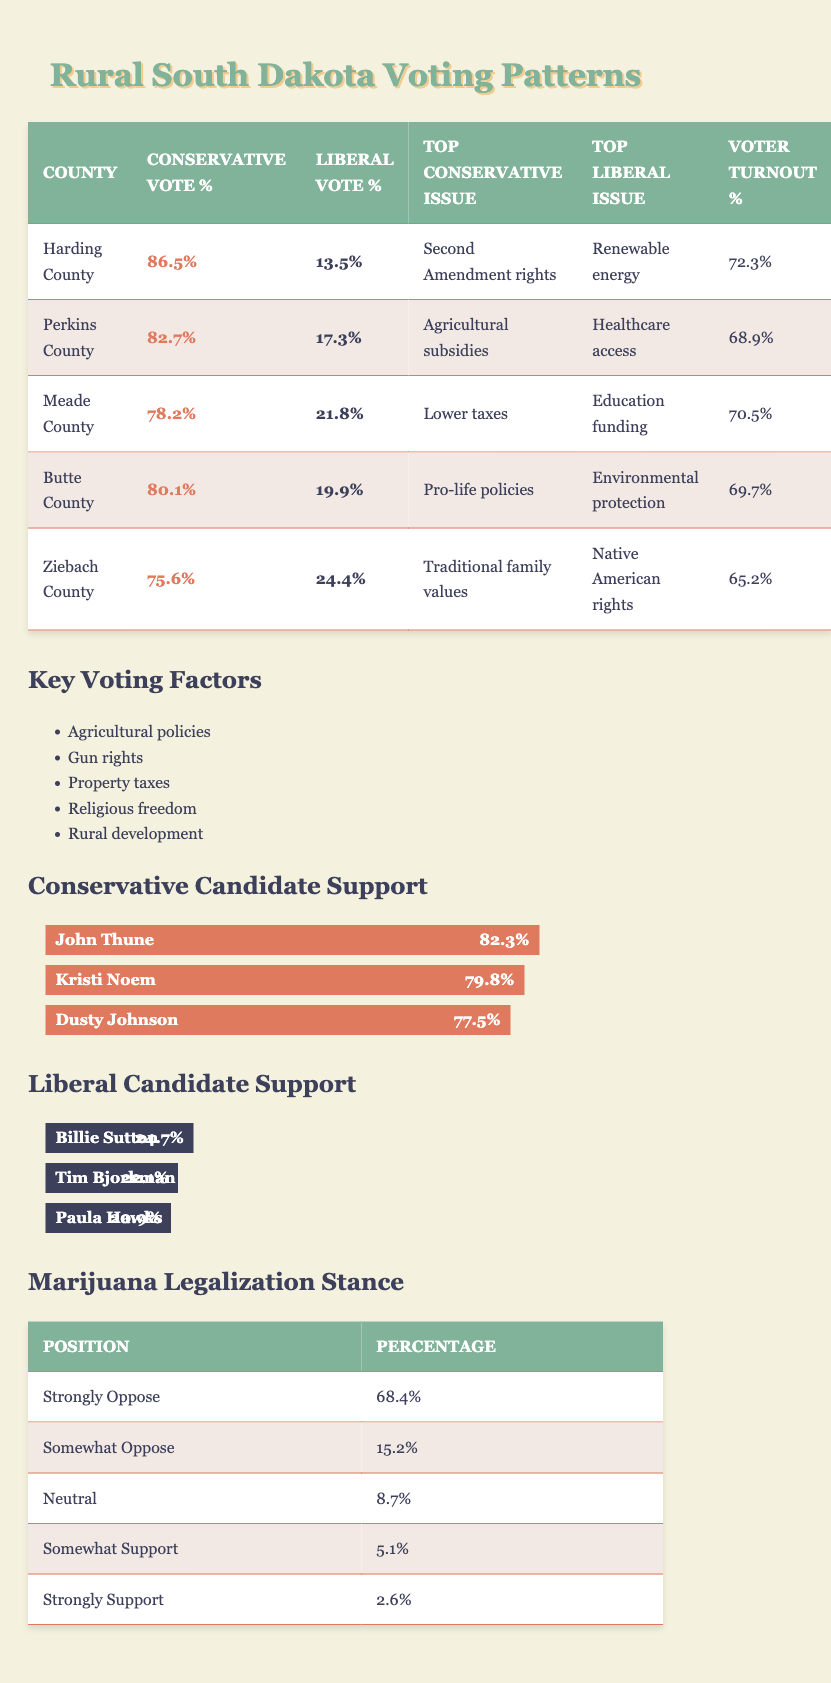What is the highest conservative vote percentage among the counties listed? Harding County has the highest conservative vote percentage at 86.5 percent. This is evidenced by looking at the "Conservative Vote %" column in the table.
Answer: 86.5% Which county has the lowest liberal vote percentage? Ziebach County has the lowest liberal vote percentage at 24.4 percent. This can be determined by identifying the smallest value in the "Liberal Vote %" column.
Answer: 24.4% What is the voter turnout percentage for Meade County? The voter turnout percentage for Meade County is 70.5 percent, which can be found in the "Voter Turnout %" column corresponding to Meade County in the table.
Answer: 70.5% Calculate the average voter turnout for all five counties. To calculate the average, sum the voter turnout percentages: 72.3 + 68.9 + 70.5 + 69.7 + 65.2 = 346.6. There are 5 counties, so the average is 346.6 / 5 = 69.32 percent.
Answer: 69.32% Is there any county that has a top conservative issue related to healthcare? No, none of the counties list healthcare as a top conservative issue. The top conservative issues for all counties are related to gun rights, agricultural policies, taxes, and pro-life policies.
Answer: No Which county has a more significant liberal vote percentage: Meade County or Butte County? Meade County has a liberal vote percentage of 21.8 percent, while Butte County has a liberal vote percentage of 19.9 percent. Therefore, Meade County has a more significant liberal vote percentage.
Answer: Meade County What is the total percentage of voters who oppose marijuana legalization (both strongly and somewhat)? To find the total percentage, add the two percentages together: 68.4 percent (strongly oppose) + 15.2 percent (somewhat oppose) = 83.6 percent.
Answer: 83.6% Which county's top liberal issue is related to education funding? Meade County's top liberal issue is education funding. This can be confirmed by checking the "Top Liberal Issue" column for Meade County.
Answer: Meade County What is the difference in conservative vote percentage between Harding County and Ziebach County? Harding County has a conservative vote percentage of 86.5 percent, while Ziebach County has 75.6 percent. The difference is 86.5 - 75.6 = 10.9 percent.
Answer: 10.9% 